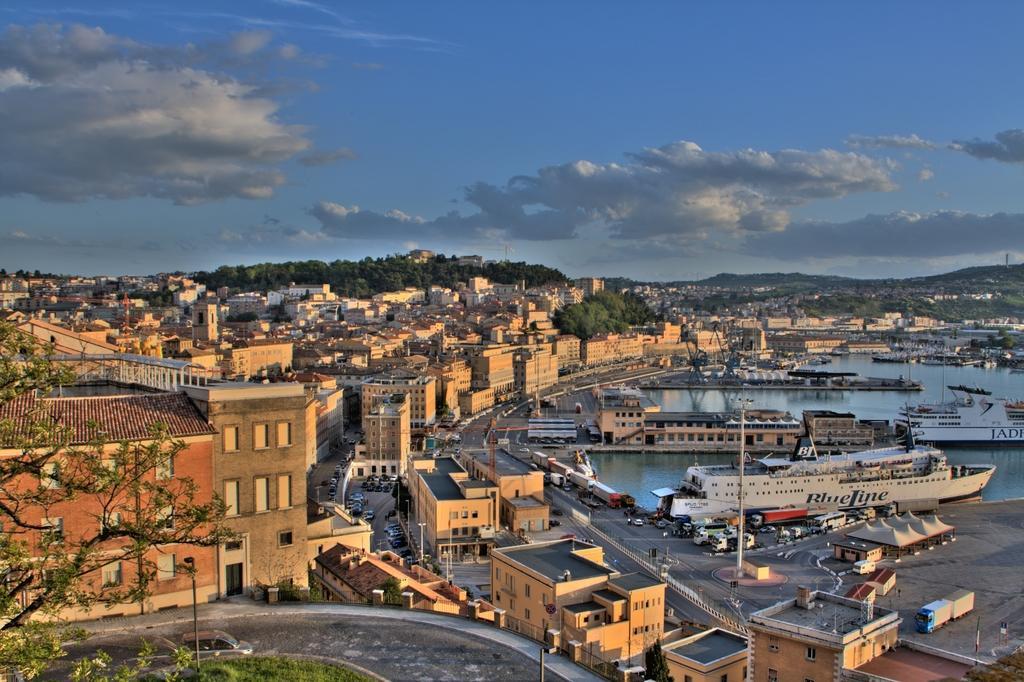Describe this image in one or two sentences. In this image we can see buildings, beside that we can see trees, at the bottom we can see the grass. And we can see vehicles on the road, on the right we can see ships and water. And we can see hills in the background, at the top we can see the sky with clouds. 